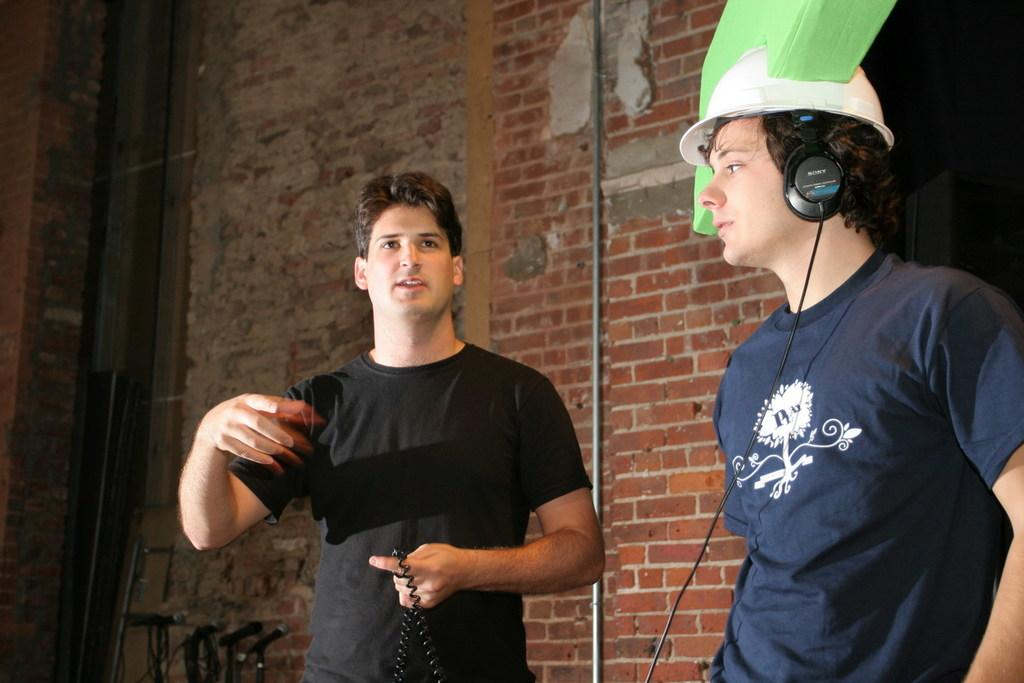What is the main subject in the center of the image? There is a boy in the center of the image. What is the boy in the center holding in his hand? The boy in the center is holding a wire in his hand. Are there any other people visible in the image? Yes, there is another boy on the right side of the image. What type of ring can be seen on the boy's finger in the image? There is no ring visible on the boy's finger in the image. How many times has the boy on the right side of the image folded his arms in the image? There is no indication of the boy on the right side folding his arms in the image. 